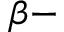<formula> <loc_0><loc_0><loc_500><loc_500>\beta -</formula> 